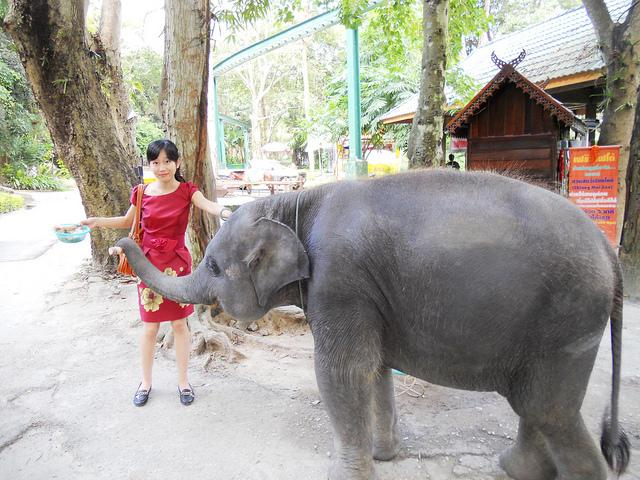What does the elephant here seek? Please explain your reasoning. food. She is holding a bowl of food and the elephant is reaching for it. 